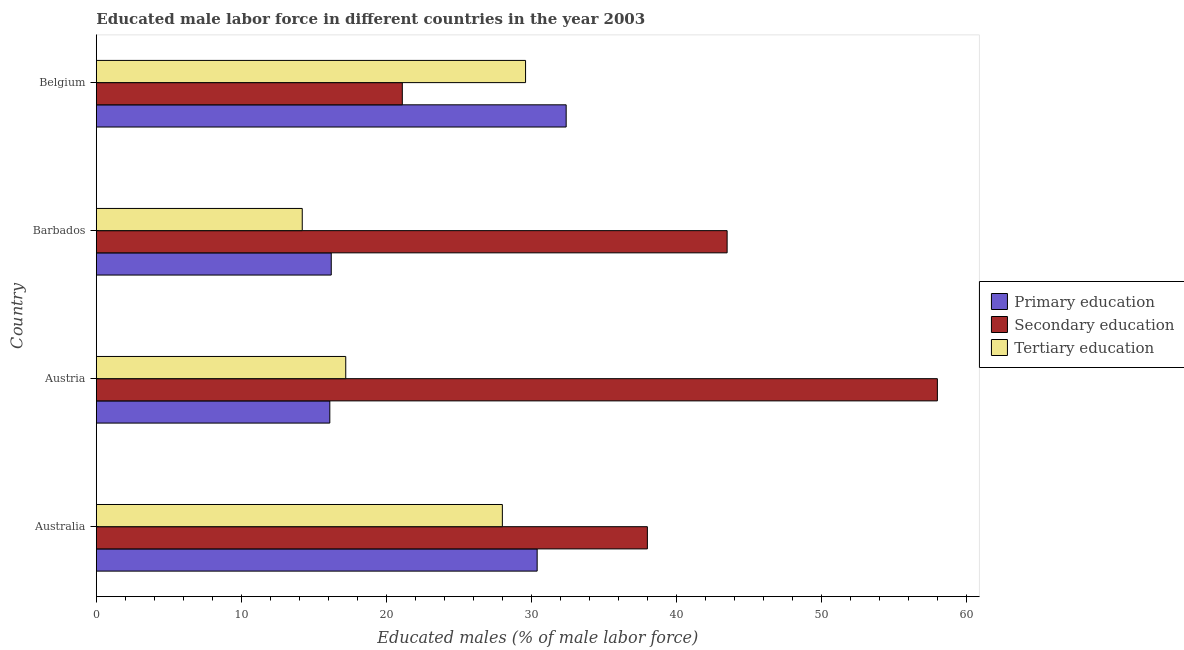How many different coloured bars are there?
Give a very brief answer. 3. How many groups of bars are there?
Your answer should be compact. 4. Are the number of bars per tick equal to the number of legend labels?
Your response must be concise. Yes. How many bars are there on the 2nd tick from the top?
Make the answer very short. 3. How many bars are there on the 2nd tick from the bottom?
Your answer should be compact. 3. What is the percentage of male labor force who received primary education in Australia?
Offer a terse response. 30.4. Across all countries, what is the maximum percentage of male labor force who received secondary education?
Your answer should be very brief. 58. Across all countries, what is the minimum percentage of male labor force who received secondary education?
Provide a short and direct response. 21.1. In which country was the percentage of male labor force who received tertiary education minimum?
Your answer should be very brief. Barbados. What is the total percentage of male labor force who received secondary education in the graph?
Offer a very short reply. 160.6. What is the difference between the percentage of male labor force who received primary education in Austria and that in Barbados?
Make the answer very short. -0.1. What is the difference between the percentage of male labor force who received primary education in Australia and the percentage of male labor force who received tertiary education in Barbados?
Provide a succinct answer. 16.2. What is the average percentage of male labor force who received primary education per country?
Provide a succinct answer. 23.77. What is the difference between the percentage of male labor force who received secondary education and percentage of male labor force who received tertiary education in Austria?
Offer a terse response. 40.8. In how many countries, is the percentage of male labor force who received primary education greater than 8 %?
Your answer should be compact. 4. What is the ratio of the percentage of male labor force who received secondary education in Australia to that in Barbados?
Ensure brevity in your answer.  0.87. Is the difference between the percentage of male labor force who received tertiary education in Australia and Austria greater than the difference between the percentage of male labor force who received secondary education in Australia and Austria?
Keep it short and to the point. Yes. What is the difference between the highest and the second highest percentage of male labor force who received tertiary education?
Make the answer very short. 1.6. In how many countries, is the percentage of male labor force who received primary education greater than the average percentage of male labor force who received primary education taken over all countries?
Your answer should be very brief. 2. What does the 2nd bar from the top in Belgium represents?
Your answer should be compact. Secondary education. What does the 2nd bar from the bottom in Belgium represents?
Provide a short and direct response. Secondary education. Are all the bars in the graph horizontal?
Ensure brevity in your answer.  Yes. How many countries are there in the graph?
Offer a very short reply. 4. Are the values on the major ticks of X-axis written in scientific E-notation?
Provide a short and direct response. No. Does the graph contain any zero values?
Your response must be concise. No. How many legend labels are there?
Your answer should be compact. 3. What is the title of the graph?
Your answer should be compact. Educated male labor force in different countries in the year 2003. Does "Renewable sources" appear as one of the legend labels in the graph?
Keep it short and to the point. No. What is the label or title of the X-axis?
Offer a terse response. Educated males (% of male labor force). What is the Educated males (% of male labor force) of Primary education in Australia?
Make the answer very short. 30.4. What is the Educated males (% of male labor force) of Primary education in Austria?
Provide a succinct answer. 16.1. What is the Educated males (% of male labor force) in Secondary education in Austria?
Your answer should be very brief. 58. What is the Educated males (% of male labor force) of Tertiary education in Austria?
Offer a terse response. 17.2. What is the Educated males (% of male labor force) of Primary education in Barbados?
Provide a short and direct response. 16.2. What is the Educated males (% of male labor force) in Secondary education in Barbados?
Ensure brevity in your answer.  43.5. What is the Educated males (% of male labor force) in Tertiary education in Barbados?
Your answer should be very brief. 14.2. What is the Educated males (% of male labor force) in Primary education in Belgium?
Ensure brevity in your answer.  32.4. What is the Educated males (% of male labor force) in Secondary education in Belgium?
Provide a succinct answer. 21.1. What is the Educated males (% of male labor force) in Tertiary education in Belgium?
Keep it short and to the point. 29.6. Across all countries, what is the maximum Educated males (% of male labor force) of Primary education?
Your answer should be compact. 32.4. Across all countries, what is the maximum Educated males (% of male labor force) in Secondary education?
Your answer should be compact. 58. Across all countries, what is the maximum Educated males (% of male labor force) in Tertiary education?
Your answer should be compact. 29.6. Across all countries, what is the minimum Educated males (% of male labor force) in Primary education?
Keep it short and to the point. 16.1. Across all countries, what is the minimum Educated males (% of male labor force) in Secondary education?
Ensure brevity in your answer.  21.1. Across all countries, what is the minimum Educated males (% of male labor force) in Tertiary education?
Keep it short and to the point. 14.2. What is the total Educated males (% of male labor force) in Primary education in the graph?
Your answer should be very brief. 95.1. What is the total Educated males (% of male labor force) of Secondary education in the graph?
Give a very brief answer. 160.6. What is the total Educated males (% of male labor force) of Tertiary education in the graph?
Ensure brevity in your answer.  89. What is the difference between the Educated males (% of male labor force) of Primary education in Australia and that in Austria?
Your response must be concise. 14.3. What is the difference between the Educated males (% of male labor force) in Secondary education in Australia and that in Austria?
Give a very brief answer. -20. What is the difference between the Educated males (% of male labor force) of Secondary education in Australia and that in Barbados?
Provide a succinct answer. -5.5. What is the difference between the Educated males (% of male labor force) of Primary education in Austria and that in Barbados?
Offer a terse response. -0.1. What is the difference between the Educated males (% of male labor force) in Secondary education in Austria and that in Barbados?
Your response must be concise. 14.5. What is the difference between the Educated males (% of male labor force) in Tertiary education in Austria and that in Barbados?
Give a very brief answer. 3. What is the difference between the Educated males (% of male labor force) in Primary education in Austria and that in Belgium?
Your answer should be compact. -16.3. What is the difference between the Educated males (% of male labor force) in Secondary education in Austria and that in Belgium?
Your answer should be very brief. 36.9. What is the difference between the Educated males (% of male labor force) of Primary education in Barbados and that in Belgium?
Provide a succinct answer. -16.2. What is the difference between the Educated males (% of male labor force) of Secondary education in Barbados and that in Belgium?
Offer a very short reply. 22.4. What is the difference between the Educated males (% of male labor force) in Tertiary education in Barbados and that in Belgium?
Make the answer very short. -15.4. What is the difference between the Educated males (% of male labor force) in Primary education in Australia and the Educated males (% of male labor force) in Secondary education in Austria?
Provide a succinct answer. -27.6. What is the difference between the Educated males (% of male labor force) in Secondary education in Australia and the Educated males (% of male labor force) in Tertiary education in Austria?
Your answer should be very brief. 20.8. What is the difference between the Educated males (% of male labor force) in Primary education in Australia and the Educated males (% of male labor force) in Secondary education in Barbados?
Provide a short and direct response. -13.1. What is the difference between the Educated males (% of male labor force) of Primary education in Australia and the Educated males (% of male labor force) of Tertiary education in Barbados?
Your answer should be compact. 16.2. What is the difference between the Educated males (% of male labor force) of Secondary education in Australia and the Educated males (% of male labor force) of Tertiary education in Barbados?
Your answer should be very brief. 23.8. What is the difference between the Educated males (% of male labor force) of Secondary education in Australia and the Educated males (% of male labor force) of Tertiary education in Belgium?
Provide a short and direct response. 8.4. What is the difference between the Educated males (% of male labor force) in Primary education in Austria and the Educated males (% of male labor force) in Secondary education in Barbados?
Keep it short and to the point. -27.4. What is the difference between the Educated males (% of male labor force) in Primary education in Austria and the Educated males (% of male labor force) in Tertiary education in Barbados?
Make the answer very short. 1.9. What is the difference between the Educated males (% of male labor force) in Secondary education in Austria and the Educated males (% of male labor force) in Tertiary education in Barbados?
Ensure brevity in your answer.  43.8. What is the difference between the Educated males (% of male labor force) of Primary education in Austria and the Educated males (% of male labor force) of Secondary education in Belgium?
Make the answer very short. -5. What is the difference between the Educated males (% of male labor force) of Primary education in Austria and the Educated males (% of male labor force) of Tertiary education in Belgium?
Provide a succinct answer. -13.5. What is the difference between the Educated males (% of male labor force) of Secondary education in Austria and the Educated males (% of male labor force) of Tertiary education in Belgium?
Give a very brief answer. 28.4. What is the difference between the Educated males (% of male labor force) of Primary education in Barbados and the Educated males (% of male labor force) of Secondary education in Belgium?
Your answer should be very brief. -4.9. What is the average Educated males (% of male labor force) of Primary education per country?
Make the answer very short. 23.77. What is the average Educated males (% of male labor force) in Secondary education per country?
Provide a short and direct response. 40.15. What is the average Educated males (% of male labor force) in Tertiary education per country?
Provide a succinct answer. 22.25. What is the difference between the Educated males (% of male labor force) of Secondary education and Educated males (% of male labor force) of Tertiary education in Australia?
Ensure brevity in your answer.  10. What is the difference between the Educated males (% of male labor force) in Primary education and Educated males (% of male labor force) in Secondary education in Austria?
Give a very brief answer. -41.9. What is the difference between the Educated males (% of male labor force) of Primary education and Educated males (% of male labor force) of Tertiary education in Austria?
Give a very brief answer. -1.1. What is the difference between the Educated males (% of male labor force) in Secondary education and Educated males (% of male labor force) in Tertiary education in Austria?
Keep it short and to the point. 40.8. What is the difference between the Educated males (% of male labor force) in Primary education and Educated males (% of male labor force) in Secondary education in Barbados?
Provide a succinct answer. -27.3. What is the difference between the Educated males (% of male labor force) in Secondary education and Educated males (% of male labor force) in Tertiary education in Barbados?
Your response must be concise. 29.3. What is the difference between the Educated males (% of male labor force) of Secondary education and Educated males (% of male labor force) of Tertiary education in Belgium?
Provide a succinct answer. -8.5. What is the ratio of the Educated males (% of male labor force) in Primary education in Australia to that in Austria?
Your answer should be very brief. 1.89. What is the ratio of the Educated males (% of male labor force) in Secondary education in Australia to that in Austria?
Your answer should be compact. 0.66. What is the ratio of the Educated males (% of male labor force) in Tertiary education in Australia to that in Austria?
Provide a succinct answer. 1.63. What is the ratio of the Educated males (% of male labor force) of Primary education in Australia to that in Barbados?
Ensure brevity in your answer.  1.88. What is the ratio of the Educated males (% of male labor force) of Secondary education in Australia to that in Barbados?
Ensure brevity in your answer.  0.87. What is the ratio of the Educated males (% of male labor force) of Tertiary education in Australia to that in Barbados?
Keep it short and to the point. 1.97. What is the ratio of the Educated males (% of male labor force) of Primary education in Australia to that in Belgium?
Make the answer very short. 0.94. What is the ratio of the Educated males (% of male labor force) of Secondary education in Australia to that in Belgium?
Your answer should be very brief. 1.8. What is the ratio of the Educated males (% of male labor force) in Tertiary education in Australia to that in Belgium?
Offer a terse response. 0.95. What is the ratio of the Educated males (% of male labor force) of Primary education in Austria to that in Barbados?
Make the answer very short. 0.99. What is the ratio of the Educated males (% of male labor force) in Secondary education in Austria to that in Barbados?
Provide a short and direct response. 1.33. What is the ratio of the Educated males (% of male labor force) of Tertiary education in Austria to that in Barbados?
Keep it short and to the point. 1.21. What is the ratio of the Educated males (% of male labor force) in Primary education in Austria to that in Belgium?
Offer a very short reply. 0.5. What is the ratio of the Educated males (% of male labor force) in Secondary education in Austria to that in Belgium?
Your answer should be very brief. 2.75. What is the ratio of the Educated males (% of male labor force) of Tertiary education in Austria to that in Belgium?
Keep it short and to the point. 0.58. What is the ratio of the Educated males (% of male labor force) in Secondary education in Barbados to that in Belgium?
Your answer should be very brief. 2.06. What is the ratio of the Educated males (% of male labor force) of Tertiary education in Barbados to that in Belgium?
Your answer should be very brief. 0.48. What is the difference between the highest and the second highest Educated males (% of male labor force) in Secondary education?
Offer a very short reply. 14.5. What is the difference between the highest and the lowest Educated males (% of male labor force) in Primary education?
Your response must be concise. 16.3. What is the difference between the highest and the lowest Educated males (% of male labor force) of Secondary education?
Give a very brief answer. 36.9. 